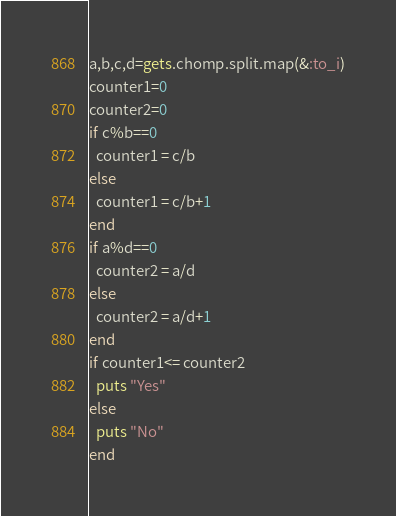<code> <loc_0><loc_0><loc_500><loc_500><_Ruby_>a,b,c,d=gets.chomp.split.map(&:to_i)
counter1=0
counter2=0
if c%b==0
  counter1 = c/b
else 
  counter1 = c/b+1
end
if a%d==0
  counter2 = a/d
else 
  counter2 = a/d+1
end
if counter1<= counter2
  puts "Yes"
else
  puts "No"
end  </code> 